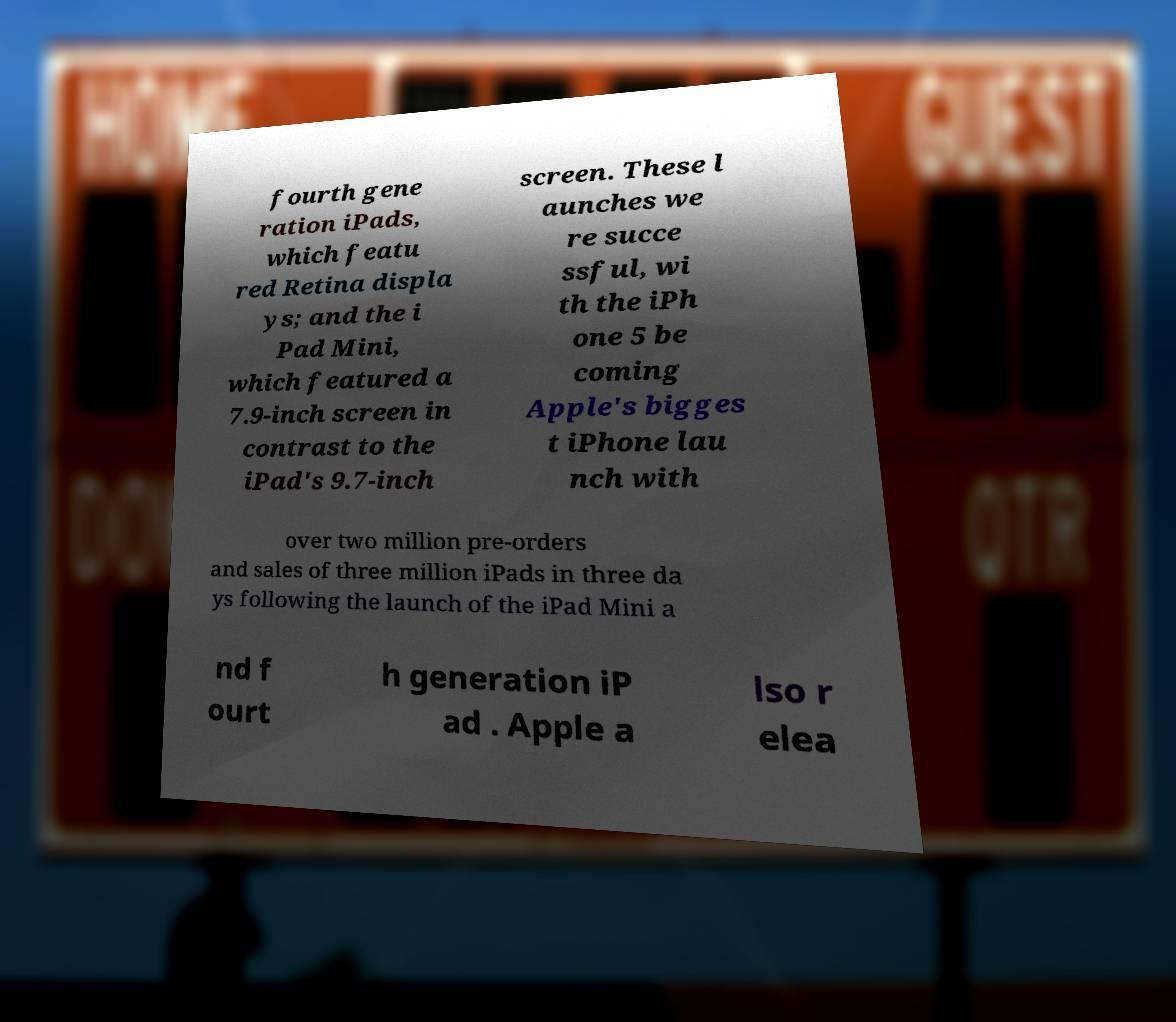Please identify and transcribe the text found in this image. fourth gene ration iPads, which featu red Retina displa ys; and the i Pad Mini, which featured a 7.9-inch screen in contrast to the iPad's 9.7-inch screen. These l aunches we re succe ssful, wi th the iPh one 5 be coming Apple's bigges t iPhone lau nch with over two million pre-orders and sales of three million iPads in three da ys following the launch of the iPad Mini a nd f ourt h generation iP ad . Apple a lso r elea 